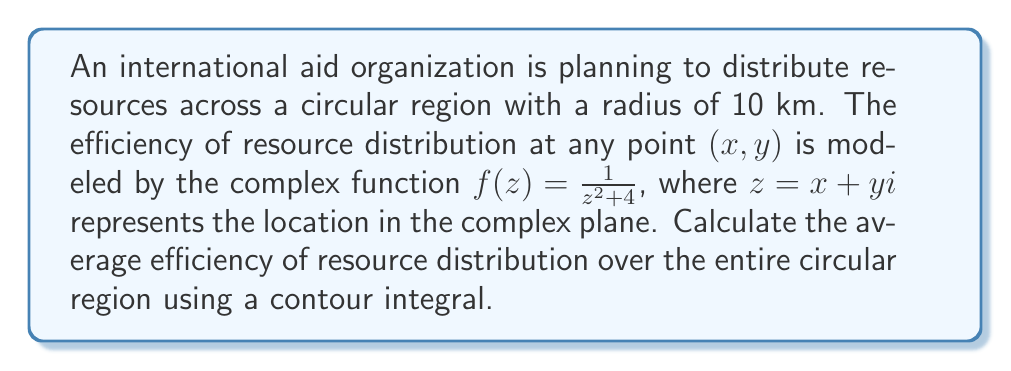Provide a solution to this math problem. To solve this problem, we'll use the mean value property for harmonic functions and apply it to our complex function. Here's the step-by-step approach:

1) The mean value of a function $f(z)$ over a circle with radius $R$ centered at the origin is given by:

   $$\frac{1}{2\pi R} \oint_{|z|=R} f(z) dz$$

2) In our case, $R = 10$ and $f(z) = \frac{1}{z^2 + 4}$

3) We need to evaluate:

   $$\frac{1}{20\pi} \oint_{|z|=10} \frac{1}{z^2 + 4} dz$$

4) To evaluate this contour integral, we'll use the residue theorem. The residues of $f(z)$ are at $z = \pm 2i$

5) The residues are:

   $$\text{Res}(f, 2i) = \lim_{z \to 2i} \frac{1}{z+2i} = \frac{1}{4i}$$
   $$\text{Res}(f, -2i) = \lim_{z \to -2i} \frac{1}{z-2i} = -\frac{1}{4i}$$

6) Only the residue at $z = 2i$ is inside our contour. By the residue theorem:

   $$\oint_{|z|=10} \frac{1}{z^2 + 4} dz = 2\pi i \cdot \text{Res}(f, 2i) = 2\pi i \cdot \frac{1}{4i} = \frac{\pi}{2}$$

7) Therefore, the average efficiency is:

   $$\frac{1}{20\pi} \cdot \frac{\pi}{2} = \frac{1}{40}$$
Answer: The average efficiency of resource distribution over the entire circular region is $\frac{1}{40}$ or $0.025$. 